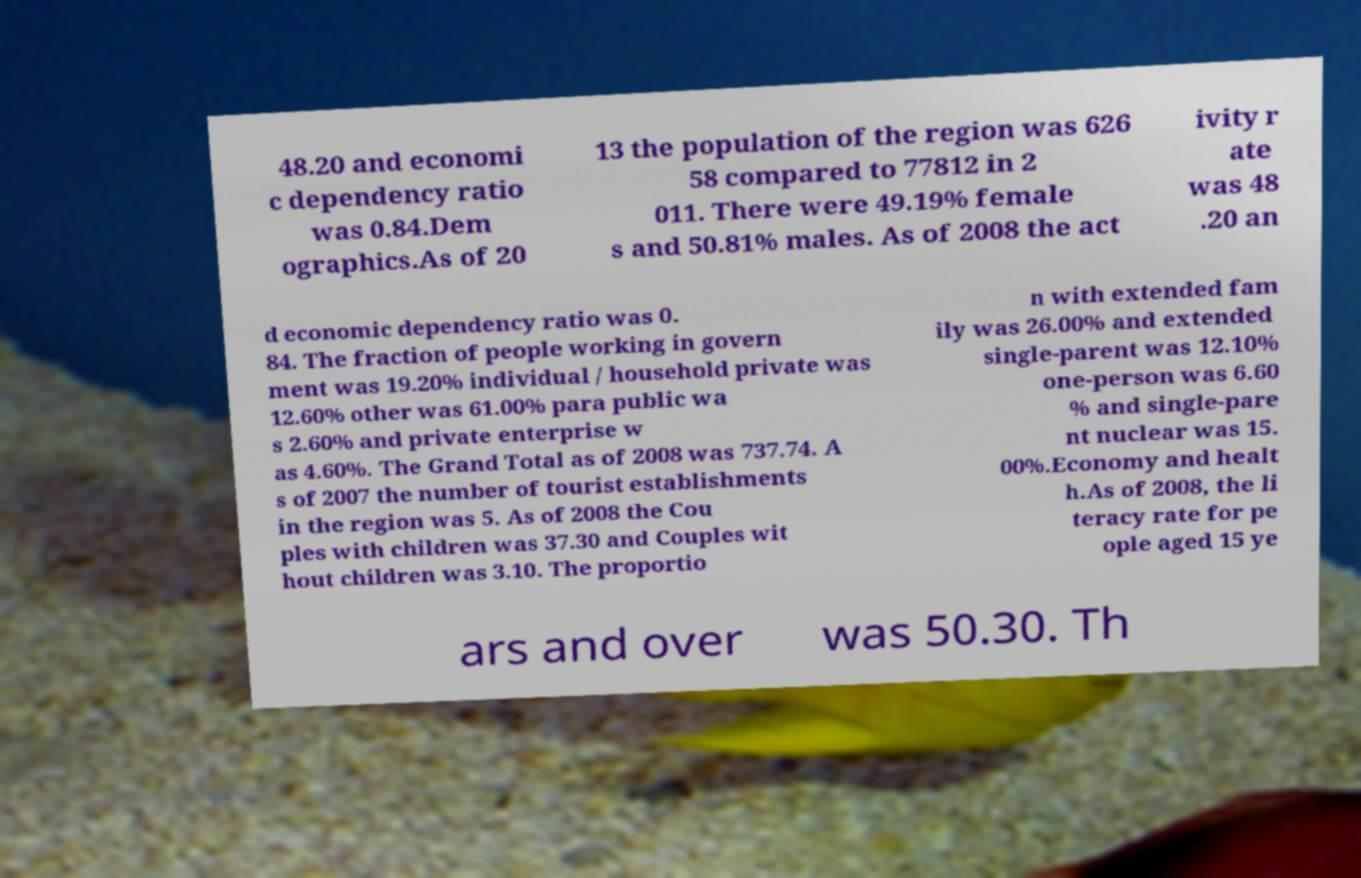Could you assist in decoding the text presented in this image and type it out clearly? 48.20 and economi c dependency ratio was 0.84.Dem ographics.As of 20 13 the population of the region was 626 58 compared to 77812 in 2 011. There were 49.19% female s and 50.81% males. As of 2008 the act ivity r ate was 48 .20 an d economic dependency ratio was 0. 84. The fraction of people working in govern ment was 19.20% individual / household private was 12.60% other was 61.00% para public wa s 2.60% and private enterprise w as 4.60%. The Grand Total as of 2008 was 737.74. A s of 2007 the number of tourist establishments in the region was 5. As of 2008 the Cou ples with children was 37.30 and Couples wit hout children was 3.10. The proportio n with extended fam ily was 26.00% and extended single-parent was 12.10% one-person was 6.60 % and single-pare nt nuclear was 15. 00%.Economy and healt h.As of 2008, the li teracy rate for pe ople aged 15 ye ars and over was 50.30. Th 